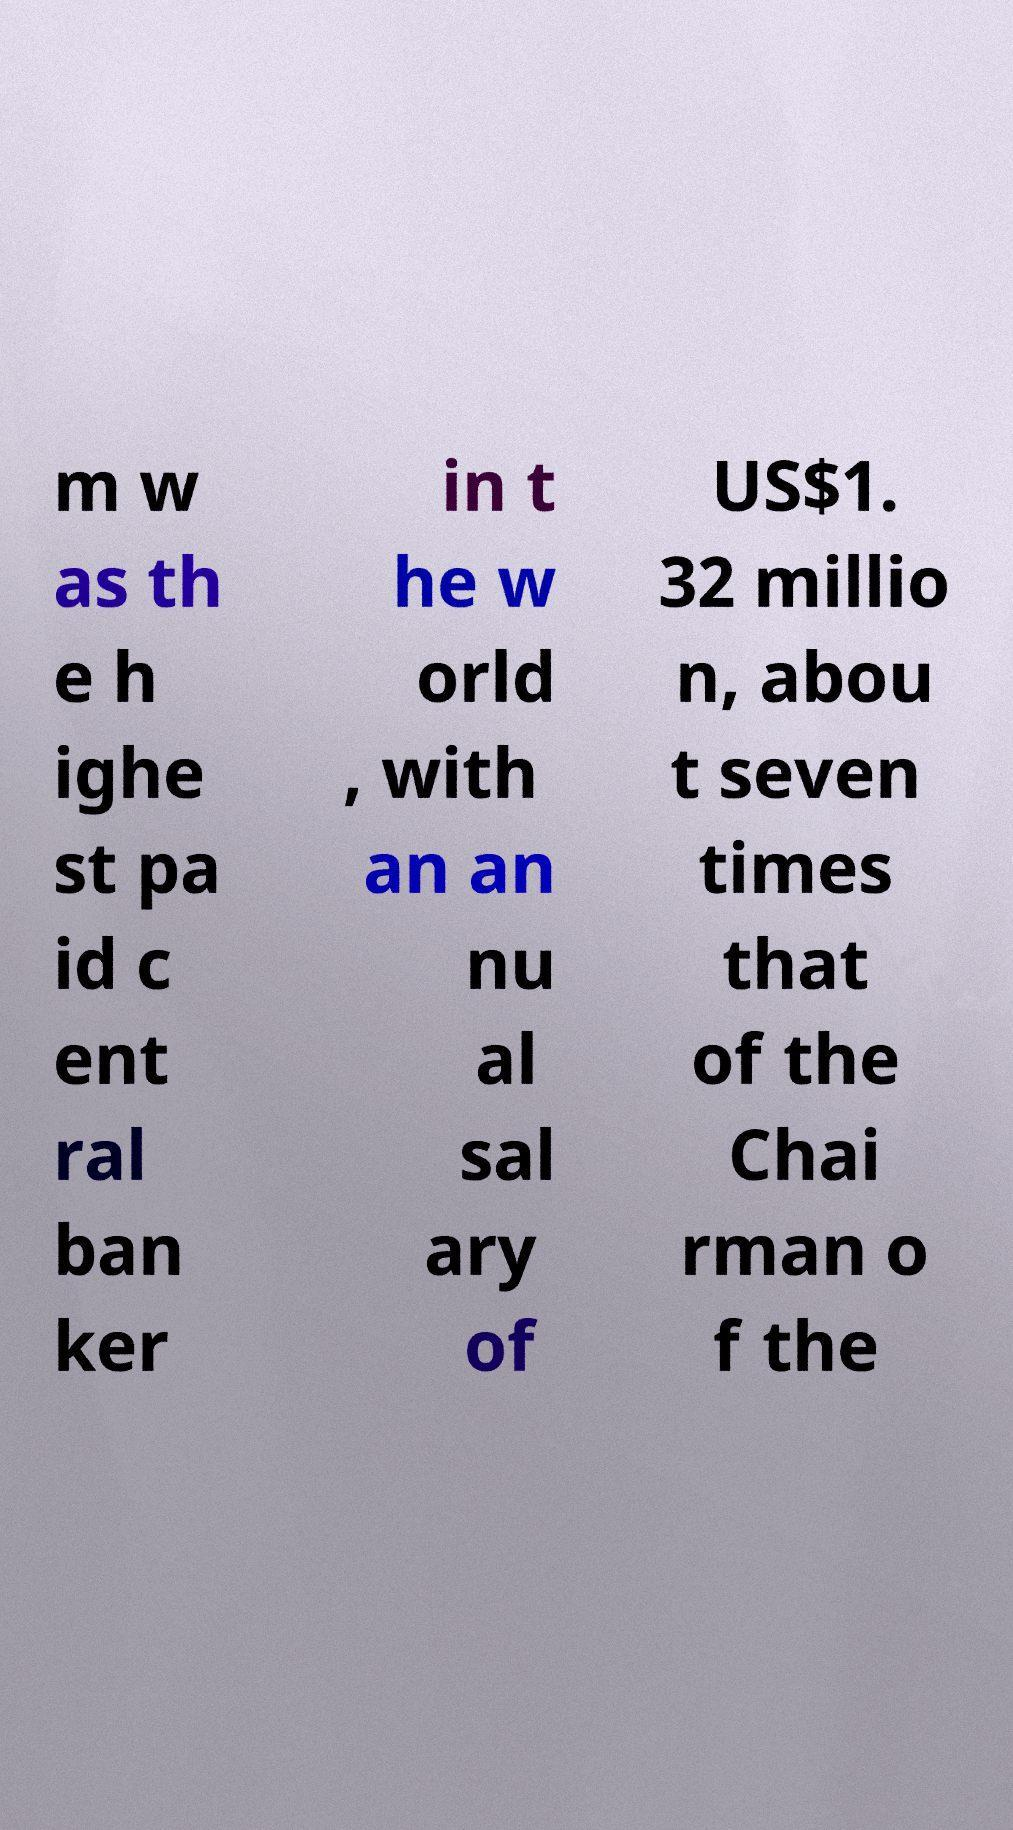Please read and relay the text visible in this image. What does it say? m w as th e h ighe st pa id c ent ral ban ker in t he w orld , with an an nu al sal ary of US$1. 32 millio n, abou t seven times that of the Chai rman o f the 